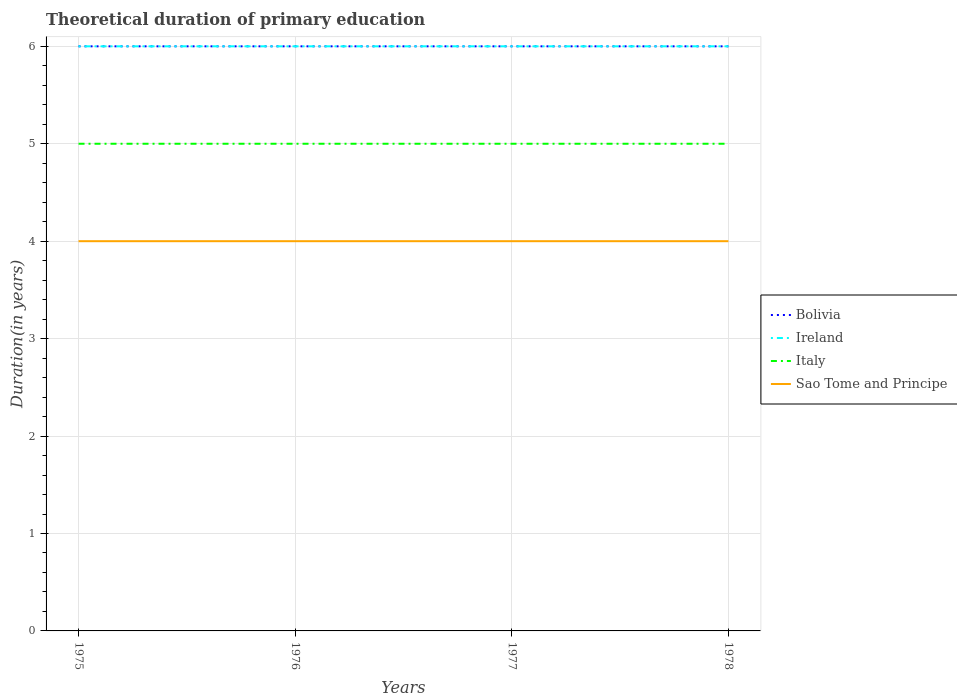How many different coloured lines are there?
Give a very brief answer. 4. Is the number of lines equal to the number of legend labels?
Make the answer very short. Yes. Across all years, what is the maximum total theoretical duration of primary education in Ireland?
Keep it short and to the point. 6. In which year was the total theoretical duration of primary education in Sao Tome and Principe maximum?
Your answer should be very brief. 1975. What is the total total theoretical duration of primary education in Ireland in the graph?
Provide a succinct answer. 0. How many lines are there?
Give a very brief answer. 4. How many years are there in the graph?
Your response must be concise. 4. What is the difference between two consecutive major ticks on the Y-axis?
Provide a succinct answer. 1. Are the values on the major ticks of Y-axis written in scientific E-notation?
Make the answer very short. No. How many legend labels are there?
Offer a very short reply. 4. What is the title of the graph?
Provide a succinct answer. Theoretical duration of primary education. What is the label or title of the Y-axis?
Keep it short and to the point. Duration(in years). What is the Duration(in years) of Bolivia in 1975?
Ensure brevity in your answer.  6. What is the Duration(in years) of Ireland in 1975?
Provide a short and direct response. 6. What is the Duration(in years) of Sao Tome and Principe in 1975?
Provide a succinct answer. 4. What is the Duration(in years) of Italy in 1976?
Ensure brevity in your answer.  5. What is the Duration(in years) of Sao Tome and Principe in 1976?
Offer a terse response. 4. What is the Duration(in years) in Sao Tome and Principe in 1978?
Provide a short and direct response. 4. Across all years, what is the maximum Duration(in years) in Bolivia?
Provide a short and direct response. 6. Across all years, what is the minimum Duration(in years) in Bolivia?
Offer a very short reply. 6. Across all years, what is the minimum Duration(in years) in Sao Tome and Principe?
Make the answer very short. 4. What is the total Duration(in years) in Italy in the graph?
Provide a succinct answer. 20. What is the difference between the Duration(in years) in Bolivia in 1975 and that in 1976?
Offer a terse response. 0. What is the difference between the Duration(in years) of Ireland in 1975 and that in 1976?
Your answer should be very brief. 0. What is the difference between the Duration(in years) in Italy in 1975 and that in 1976?
Your answer should be compact. 0. What is the difference between the Duration(in years) in Bolivia in 1975 and that in 1977?
Your answer should be compact. 0. What is the difference between the Duration(in years) of Ireland in 1976 and that in 1977?
Your answer should be compact. 0. What is the difference between the Duration(in years) of Italy in 1976 and that in 1977?
Your answer should be very brief. 0. What is the difference between the Duration(in years) of Sao Tome and Principe in 1976 and that in 1977?
Your answer should be very brief. 0. What is the difference between the Duration(in years) in Ireland in 1976 and that in 1978?
Provide a short and direct response. 0. What is the difference between the Duration(in years) of Italy in 1976 and that in 1978?
Offer a terse response. 0. What is the difference between the Duration(in years) of Sao Tome and Principe in 1976 and that in 1978?
Give a very brief answer. 0. What is the difference between the Duration(in years) of Bolivia in 1975 and the Duration(in years) of Ireland in 1976?
Make the answer very short. 0. What is the difference between the Duration(in years) of Bolivia in 1975 and the Duration(in years) of Italy in 1976?
Your answer should be compact. 1. What is the difference between the Duration(in years) in Bolivia in 1975 and the Duration(in years) in Sao Tome and Principe in 1976?
Your response must be concise. 2. What is the difference between the Duration(in years) in Italy in 1975 and the Duration(in years) in Sao Tome and Principe in 1976?
Your response must be concise. 1. What is the difference between the Duration(in years) in Bolivia in 1975 and the Duration(in years) in Ireland in 1977?
Your answer should be very brief. 0. What is the difference between the Duration(in years) of Bolivia in 1975 and the Duration(in years) of Sao Tome and Principe in 1977?
Provide a short and direct response. 2. What is the difference between the Duration(in years) in Ireland in 1975 and the Duration(in years) in Italy in 1977?
Your response must be concise. 1. What is the difference between the Duration(in years) of Ireland in 1975 and the Duration(in years) of Sao Tome and Principe in 1977?
Provide a short and direct response. 2. What is the difference between the Duration(in years) of Italy in 1975 and the Duration(in years) of Sao Tome and Principe in 1977?
Offer a terse response. 1. What is the difference between the Duration(in years) in Bolivia in 1975 and the Duration(in years) in Ireland in 1978?
Keep it short and to the point. 0. What is the difference between the Duration(in years) in Bolivia in 1975 and the Duration(in years) in Italy in 1978?
Offer a terse response. 1. What is the difference between the Duration(in years) of Ireland in 1975 and the Duration(in years) of Italy in 1978?
Offer a terse response. 1. What is the difference between the Duration(in years) of Bolivia in 1976 and the Duration(in years) of Ireland in 1977?
Keep it short and to the point. 0. What is the difference between the Duration(in years) in Ireland in 1976 and the Duration(in years) in Italy in 1977?
Offer a very short reply. 1. What is the difference between the Duration(in years) of Italy in 1976 and the Duration(in years) of Sao Tome and Principe in 1977?
Ensure brevity in your answer.  1. What is the difference between the Duration(in years) of Bolivia in 1976 and the Duration(in years) of Ireland in 1978?
Keep it short and to the point. 0. What is the difference between the Duration(in years) of Ireland in 1976 and the Duration(in years) of Italy in 1978?
Your answer should be very brief. 1. What is the difference between the Duration(in years) in Bolivia in 1977 and the Duration(in years) in Ireland in 1978?
Provide a succinct answer. 0. What is the difference between the Duration(in years) in Bolivia in 1977 and the Duration(in years) in Italy in 1978?
Your answer should be compact. 1. What is the difference between the Duration(in years) in Ireland in 1977 and the Duration(in years) in Italy in 1978?
Provide a succinct answer. 1. What is the difference between the Duration(in years) in Ireland in 1977 and the Duration(in years) in Sao Tome and Principe in 1978?
Offer a very short reply. 2. What is the difference between the Duration(in years) in Italy in 1977 and the Duration(in years) in Sao Tome and Principe in 1978?
Your answer should be very brief. 1. What is the average Duration(in years) of Bolivia per year?
Your answer should be very brief. 6. What is the average Duration(in years) in Ireland per year?
Provide a succinct answer. 6. What is the average Duration(in years) of Italy per year?
Offer a very short reply. 5. In the year 1975, what is the difference between the Duration(in years) of Bolivia and Duration(in years) of Italy?
Offer a terse response. 1. In the year 1975, what is the difference between the Duration(in years) in Bolivia and Duration(in years) in Sao Tome and Principe?
Your answer should be compact. 2. In the year 1975, what is the difference between the Duration(in years) of Ireland and Duration(in years) of Sao Tome and Principe?
Give a very brief answer. 2. In the year 1976, what is the difference between the Duration(in years) of Bolivia and Duration(in years) of Sao Tome and Principe?
Your answer should be very brief. 2. In the year 1976, what is the difference between the Duration(in years) in Ireland and Duration(in years) in Sao Tome and Principe?
Give a very brief answer. 2. In the year 1977, what is the difference between the Duration(in years) in Ireland and Duration(in years) in Italy?
Give a very brief answer. 1. In the year 1977, what is the difference between the Duration(in years) in Ireland and Duration(in years) in Sao Tome and Principe?
Give a very brief answer. 2. In the year 1977, what is the difference between the Duration(in years) of Italy and Duration(in years) of Sao Tome and Principe?
Offer a terse response. 1. In the year 1978, what is the difference between the Duration(in years) of Bolivia and Duration(in years) of Ireland?
Your response must be concise. 0. In the year 1978, what is the difference between the Duration(in years) in Ireland and Duration(in years) in Sao Tome and Principe?
Offer a terse response. 2. In the year 1978, what is the difference between the Duration(in years) of Italy and Duration(in years) of Sao Tome and Principe?
Provide a short and direct response. 1. What is the ratio of the Duration(in years) of Bolivia in 1975 to that in 1976?
Your answer should be compact. 1. What is the ratio of the Duration(in years) of Ireland in 1975 to that in 1977?
Offer a terse response. 1. What is the ratio of the Duration(in years) in Sao Tome and Principe in 1975 to that in 1977?
Your answer should be very brief. 1. What is the ratio of the Duration(in years) of Bolivia in 1975 to that in 1978?
Ensure brevity in your answer.  1. What is the ratio of the Duration(in years) in Bolivia in 1976 to that in 1977?
Provide a succinct answer. 1. What is the ratio of the Duration(in years) of Sao Tome and Principe in 1976 to that in 1977?
Your answer should be very brief. 1. What is the ratio of the Duration(in years) of Bolivia in 1977 to that in 1978?
Offer a terse response. 1. What is the ratio of the Duration(in years) in Italy in 1977 to that in 1978?
Provide a succinct answer. 1. What is the ratio of the Duration(in years) in Sao Tome and Principe in 1977 to that in 1978?
Provide a short and direct response. 1. What is the difference between the highest and the second highest Duration(in years) in Bolivia?
Make the answer very short. 0. What is the difference between the highest and the second highest Duration(in years) in Sao Tome and Principe?
Offer a very short reply. 0. What is the difference between the highest and the lowest Duration(in years) in Bolivia?
Provide a short and direct response. 0. What is the difference between the highest and the lowest Duration(in years) of Sao Tome and Principe?
Your answer should be compact. 0. 